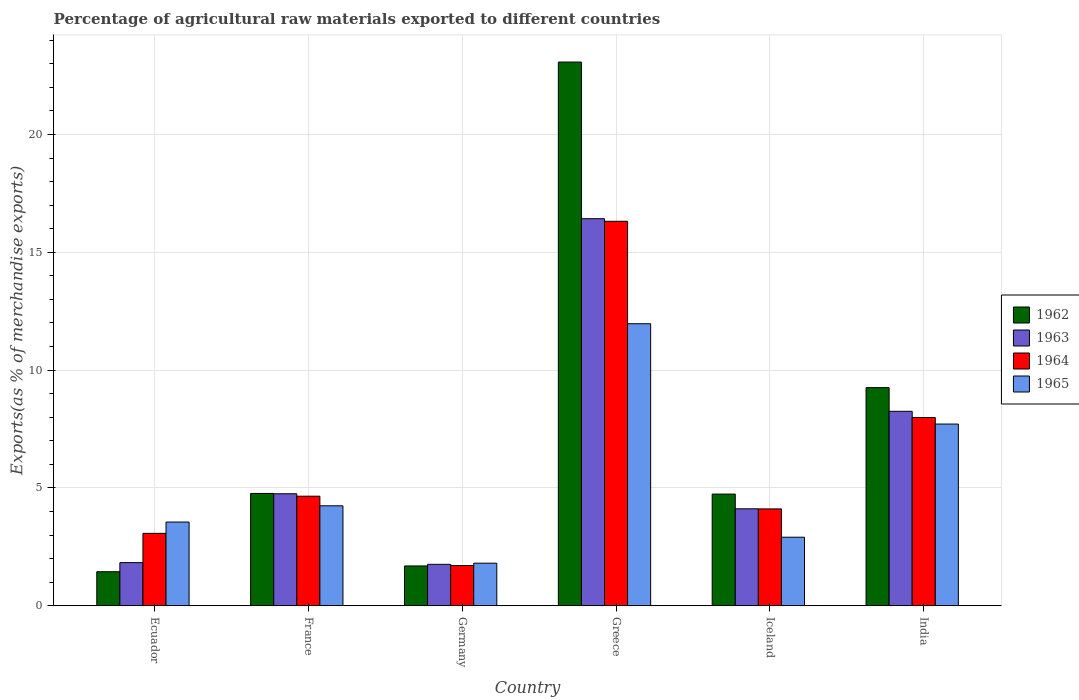How many different coloured bars are there?
Offer a terse response. 4. How many bars are there on the 6th tick from the left?
Provide a short and direct response. 4. How many bars are there on the 4th tick from the right?
Your answer should be very brief. 4. What is the percentage of exports to different countries in 1962 in Iceland?
Your answer should be compact. 4.74. Across all countries, what is the maximum percentage of exports to different countries in 1963?
Offer a terse response. 16.43. Across all countries, what is the minimum percentage of exports to different countries in 1962?
Make the answer very short. 1.45. What is the total percentage of exports to different countries in 1963 in the graph?
Give a very brief answer. 37.14. What is the difference between the percentage of exports to different countries in 1962 in Ecuador and that in India?
Offer a terse response. -7.81. What is the difference between the percentage of exports to different countries in 1962 in Iceland and the percentage of exports to different countries in 1963 in Germany?
Your answer should be compact. 2.98. What is the average percentage of exports to different countries in 1963 per country?
Keep it short and to the point. 6.19. What is the difference between the percentage of exports to different countries of/in 1964 and percentage of exports to different countries of/in 1965 in Greece?
Provide a succinct answer. 4.35. What is the ratio of the percentage of exports to different countries in 1962 in Ecuador to that in Iceland?
Keep it short and to the point. 0.3. What is the difference between the highest and the second highest percentage of exports to different countries in 1962?
Offer a terse response. 4.49. What is the difference between the highest and the lowest percentage of exports to different countries in 1962?
Ensure brevity in your answer.  21.63. Is it the case that in every country, the sum of the percentage of exports to different countries in 1963 and percentage of exports to different countries in 1964 is greater than the sum of percentage of exports to different countries in 1965 and percentage of exports to different countries in 1962?
Give a very brief answer. No. What does the 3rd bar from the left in Greece represents?
Ensure brevity in your answer.  1964. How many bars are there?
Your response must be concise. 24. How many countries are there in the graph?
Ensure brevity in your answer.  6. What is the difference between two consecutive major ticks on the Y-axis?
Provide a succinct answer. 5. Does the graph contain grids?
Your answer should be compact. Yes. How many legend labels are there?
Ensure brevity in your answer.  4. What is the title of the graph?
Provide a short and direct response. Percentage of agricultural raw materials exported to different countries. Does "1969" appear as one of the legend labels in the graph?
Your response must be concise. No. What is the label or title of the X-axis?
Make the answer very short. Country. What is the label or title of the Y-axis?
Offer a very short reply. Exports(as % of merchandise exports). What is the Exports(as % of merchandise exports) of 1962 in Ecuador?
Provide a short and direct response. 1.45. What is the Exports(as % of merchandise exports) of 1963 in Ecuador?
Offer a terse response. 1.83. What is the Exports(as % of merchandise exports) of 1964 in Ecuador?
Your response must be concise. 3.07. What is the Exports(as % of merchandise exports) of 1965 in Ecuador?
Give a very brief answer. 3.55. What is the Exports(as % of merchandise exports) of 1962 in France?
Your answer should be very brief. 4.77. What is the Exports(as % of merchandise exports) of 1963 in France?
Provide a succinct answer. 4.75. What is the Exports(as % of merchandise exports) in 1964 in France?
Your answer should be very brief. 4.65. What is the Exports(as % of merchandise exports) in 1965 in France?
Keep it short and to the point. 4.24. What is the Exports(as % of merchandise exports) in 1962 in Germany?
Provide a succinct answer. 1.69. What is the Exports(as % of merchandise exports) of 1963 in Germany?
Make the answer very short. 1.76. What is the Exports(as % of merchandise exports) in 1964 in Germany?
Your answer should be compact. 1.71. What is the Exports(as % of merchandise exports) of 1965 in Germany?
Keep it short and to the point. 1.81. What is the Exports(as % of merchandise exports) in 1962 in Greece?
Offer a very short reply. 23.07. What is the Exports(as % of merchandise exports) in 1963 in Greece?
Offer a very short reply. 16.43. What is the Exports(as % of merchandise exports) of 1964 in Greece?
Offer a very short reply. 16.32. What is the Exports(as % of merchandise exports) in 1965 in Greece?
Offer a terse response. 11.97. What is the Exports(as % of merchandise exports) in 1962 in Iceland?
Your answer should be compact. 4.74. What is the Exports(as % of merchandise exports) in 1963 in Iceland?
Keep it short and to the point. 4.12. What is the Exports(as % of merchandise exports) in 1964 in Iceland?
Give a very brief answer. 4.11. What is the Exports(as % of merchandise exports) of 1965 in Iceland?
Keep it short and to the point. 2.91. What is the Exports(as % of merchandise exports) of 1962 in India?
Provide a succinct answer. 9.26. What is the Exports(as % of merchandise exports) of 1963 in India?
Provide a short and direct response. 8.25. What is the Exports(as % of merchandise exports) of 1964 in India?
Your answer should be compact. 7.99. What is the Exports(as % of merchandise exports) of 1965 in India?
Provide a short and direct response. 7.71. Across all countries, what is the maximum Exports(as % of merchandise exports) of 1962?
Keep it short and to the point. 23.07. Across all countries, what is the maximum Exports(as % of merchandise exports) of 1963?
Your response must be concise. 16.43. Across all countries, what is the maximum Exports(as % of merchandise exports) in 1964?
Keep it short and to the point. 16.32. Across all countries, what is the maximum Exports(as % of merchandise exports) in 1965?
Make the answer very short. 11.97. Across all countries, what is the minimum Exports(as % of merchandise exports) of 1962?
Offer a terse response. 1.45. Across all countries, what is the minimum Exports(as % of merchandise exports) of 1963?
Offer a terse response. 1.76. Across all countries, what is the minimum Exports(as % of merchandise exports) in 1964?
Give a very brief answer. 1.71. Across all countries, what is the minimum Exports(as % of merchandise exports) in 1965?
Keep it short and to the point. 1.81. What is the total Exports(as % of merchandise exports) of 1962 in the graph?
Provide a short and direct response. 44.97. What is the total Exports(as % of merchandise exports) in 1963 in the graph?
Offer a terse response. 37.14. What is the total Exports(as % of merchandise exports) of 1964 in the graph?
Your response must be concise. 37.85. What is the total Exports(as % of merchandise exports) in 1965 in the graph?
Give a very brief answer. 32.2. What is the difference between the Exports(as % of merchandise exports) in 1962 in Ecuador and that in France?
Your answer should be compact. -3.32. What is the difference between the Exports(as % of merchandise exports) in 1963 in Ecuador and that in France?
Your answer should be compact. -2.92. What is the difference between the Exports(as % of merchandise exports) in 1964 in Ecuador and that in France?
Offer a very short reply. -1.58. What is the difference between the Exports(as % of merchandise exports) in 1965 in Ecuador and that in France?
Your response must be concise. -0.69. What is the difference between the Exports(as % of merchandise exports) in 1962 in Ecuador and that in Germany?
Offer a terse response. -0.24. What is the difference between the Exports(as % of merchandise exports) in 1963 in Ecuador and that in Germany?
Keep it short and to the point. 0.07. What is the difference between the Exports(as % of merchandise exports) in 1964 in Ecuador and that in Germany?
Your answer should be very brief. 1.37. What is the difference between the Exports(as % of merchandise exports) of 1965 in Ecuador and that in Germany?
Make the answer very short. 1.75. What is the difference between the Exports(as % of merchandise exports) of 1962 in Ecuador and that in Greece?
Provide a short and direct response. -21.63. What is the difference between the Exports(as % of merchandise exports) in 1963 in Ecuador and that in Greece?
Provide a short and direct response. -14.59. What is the difference between the Exports(as % of merchandise exports) in 1964 in Ecuador and that in Greece?
Your response must be concise. -13.24. What is the difference between the Exports(as % of merchandise exports) in 1965 in Ecuador and that in Greece?
Your response must be concise. -8.42. What is the difference between the Exports(as % of merchandise exports) of 1962 in Ecuador and that in Iceland?
Your response must be concise. -3.3. What is the difference between the Exports(as % of merchandise exports) of 1963 in Ecuador and that in Iceland?
Provide a short and direct response. -2.28. What is the difference between the Exports(as % of merchandise exports) in 1964 in Ecuador and that in Iceland?
Your response must be concise. -1.04. What is the difference between the Exports(as % of merchandise exports) of 1965 in Ecuador and that in Iceland?
Offer a very short reply. 0.64. What is the difference between the Exports(as % of merchandise exports) of 1962 in Ecuador and that in India?
Your answer should be very brief. -7.81. What is the difference between the Exports(as % of merchandise exports) of 1963 in Ecuador and that in India?
Your answer should be very brief. -6.42. What is the difference between the Exports(as % of merchandise exports) of 1964 in Ecuador and that in India?
Your response must be concise. -4.92. What is the difference between the Exports(as % of merchandise exports) in 1965 in Ecuador and that in India?
Provide a short and direct response. -4.16. What is the difference between the Exports(as % of merchandise exports) in 1962 in France and that in Germany?
Keep it short and to the point. 3.08. What is the difference between the Exports(as % of merchandise exports) of 1963 in France and that in Germany?
Provide a succinct answer. 2.99. What is the difference between the Exports(as % of merchandise exports) of 1964 in France and that in Germany?
Give a very brief answer. 2.94. What is the difference between the Exports(as % of merchandise exports) of 1965 in France and that in Germany?
Keep it short and to the point. 2.43. What is the difference between the Exports(as % of merchandise exports) of 1962 in France and that in Greece?
Keep it short and to the point. -18.3. What is the difference between the Exports(as % of merchandise exports) in 1963 in France and that in Greece?
Ensure brevity in your answer.  -11.67. What is the difference between the Exports(as % of merchandise exports) in 1964 in France and that in Greece?
Your answer should be very brief. -11.66. What is the difference between the Exports(as % of merchandise exports) in 1965 in France and that in Greece?
Your response must be concise. -7.73. What is the difference between the Exports(as % of merchandise exports) in 1962 in France and that in Iceland?
Provide a short and direct response. 0.03. What is the difference between the Exports(as % of merchandise exports) of 1963 in France and that in Iceland?
Keep it short and to the point. 0.64. What is the difference between the Exports(as % of merchandise exports) in 1964 in France and that in Iceland?
Give a very brief answer. 0.54. What is the difference between the Exports(as % of merchandise exports) in 1965 in France and that in Iceland?
Your response must be concise. 1.33. What is the difference between the Exports(as % of merchandise exports) of 1962 in France and that in India?
Keep it short and to the point. -4.49. What is the difference between the Exports(as % of merchandise exports) of 1963 in France and that in India?
Offer a very short reply. -3.5. What is the difference between the Exports(as % of merchandise exports) of 1964 in France and that in India?
Provide a succinct answer. -3.34. What is the difference between the Exports(as % of merchandise exports) in 1965 in France and that in India?
Give a very brief answer. -3.47. What is the difference between the Exports(as % of merchandise exports) in 1962 in Germany and that in Greece?
Your answer should be very brief. -21.38. What is the difference between the Exports(as % of merchandise exports) of 1963 in Germany and that in Greece?
Your response must be concise. -14.67. What is the difference between the Exports(as % of merchandise exports) of 1964 in Germany and that in Greece?
Your answer should be compact. -14.61. What is the difference between the Exports(as % of merchandise exports) in 1965 in Germany and that in Greece?
Give a very brief answer. -10.16. What is the difference between the Exports(as % of merchandise exports) in 1962 in Germany and that in Iceland?
Ensure brevity in your answer.  -3.05. What is the difference between the Exports(as % of merchandise exports) in 1963 in Germany and that in Iceland?
Your response must be concise. -2.36. What is the difference between the Exports(as % of merchandise exports) in 1964 in Germany and that in Iceland?
Your answer should be very brief. -2.4. What is the difference between the Exports(as % of merchandise exports) in 1965 in Germany and that in Iceland?
Offer a terse response. -1.1. What is the difference between the Exports(as % of merchandise exports) in 1962 in Germany and that in India?
Your answer should be compact. -7.57. What is the difference between the Exports(as % of merchandise exports) of 1963 in Germany and that in India?
Your answer should be very brief. -6.49. What is the difference between the Exports(as % of merchandise exports) of 1964 in Germany and that in India?
Give a very brief answer. -6.28. What is the difference between the Exports(as % of merchandise exports) in 1965 in Germany and that in India?
Keep it short and to the point. -5.9. What is the difference between the Exports(as % of merchandise exports) of 1962 in Greece and that in Iceland?
Keep it short and to the point. 18.33. What is the difference between the Exports(as % of merchandise exports) of 1963 in Greece and that in Iceland?
Provide a short and direct response. 12.31. What is the difference between the Exports(as % of merchandise exports) in 1964 in Greece and that in Iceland?
Your answer should be compact. 12.2. What is the difference between the Exports(as % of merchandise exports) of 1965 in Greece and that in Iceland?
Your answer should be compact. 9.06. What is the difference between the Exports(as % of merchandise exports) in 1962 in Greece and that in India?
Your response must be concise. 13.81. What is the difference between the Exports(as % of merchandise exports) of 1963 in Greece and that in India?
Give a very brief answer. 8.17. What is the difference between the Exports(as % of merchandise exports) of 1964 in Greece and that in India?
Your answer should be very brief. 8.33. What is the difference between the Exports(as % of merchandise exports) of 1965 in Greece and that in India?
Provide a succinct answer. 4.26. What is the difference between the Exports(as % of merchandise exports) in 1962 in Iceland and that in India?
Keep it short and to the point. -4.52. What is the difference between the Exports(as % of merchandise exports) in 1963 in Iceland and that in India?
Offer a very short reply. -4.14. What is the difference between the Exports(as % of merchandise exports) of 1964 in Iceland and that in India?
Make the answer very short. -3.88. What is the difference between the Exports(as % of merchandise exports) of 1965 in Iceland and that in India?
Ensure brevity in your answer.  -4.8. What is the difference between the Exports(as % of merchandise exports) of 1962 in Ecuador and the Exports(as % of merchandise exports) of 1963 in France?
Provide a succinct answer. -3.31. What is the difference between the Exports(as % of merchandise exports) in 1962 in Ecuador and the Exports(as % of merchandise exports) in 1964 in France?
Keep it short and to the point. -3.21. What is the difference between the Exports(as % of merchandise exports) of 1962 in Ecuador and the Exports(as % of merchandise exports) of 1965 in France?
Give a very brief answer. -2.8. What is the difference between the Exports(as % of merchandise exports) of 1963 in Ecuador and the Exports(as % of merchandise exports) of 1964 in France?
Your response must be concise. -2.82. What is the difference between the Exports(as % of merchandise exports) in 1963 in Ecuador and the Exports(as % of merchandise exports) in 1965 in France?
Provide a succinct answer. -2.41. What is the difference between the Exports(as % of merchandise exports) in 1964 in Ecuador and the Exports(as % of merchandise exports) in 1965 in France?
Your response must be concise. -1.17. What is the difference between the Exports(as % of merchandise exports) of 1962 in Ecuador and the Exports(as % of merchandise exports) of 1963 in Germany?
Ensure brevity in your answer.  -0.31. What is the difference between the Exports(as % of merchandise exports) in 1962 in Ecuador and the Exports(as % of merchandise exports) in 1964 in Germany?
Ensure brevity in your answer.  -0.26. What is the difference between the Exports(as % of merchandise exports) of 1962 in Ecuador and the Exports(as % of merchandise exports) of 1965 in Germany?
Provide a short and direct response. -0.36. What is the difference between the Exports(as % of merchandise exports) of 1963 in Ecuador and the Exports(as % of merchandise exports) of 1964 in Germany?
Keep it short and to the point. 0.12. What is the difference between the Exports(as % of merchandise exports) of 1963 in Ecuador and the Exports(as % of merchandise exports) of 1965 in Germany?
Your response must be concise. 0.02. What is the difference between the Exports(as % of merchandise exports) in 1964 in Ecuador and the Exports(as % of merchandise exports) in 1965 in Germany?
Offer a very short reply. 1.27. What is the difference between the Exports(as % of merchandise exports) in 1962 in Ecuador and the Exports(as % of merchandise exports) in 1963 in Greece?
Ensure brevity in your answer.  -14.98. What is the difference between the Exports(as % of merchandise exports) in 1962 in Ecuador and the Exports(as % of merchandise exports) in 1964 in Greece?
Give a very brief answer. -14.87. What is the difference between the Exports(as % of merchandise exports) in 1962 in Ecuador and the Exports(as % of merchandise exports) in 1965 in Greece?
Provide a short and direct response. -10.52. What is the difference between the Exports(as % of merchandise exports) in 1963 in Ecuador and the Exports(as % of merchandise exports) in 1964 in Greece?
Provide a short and direct response. -14.48. What is the difference between the Exports(as % of merchandise exports) of 1963 in Ecuador and the Exports(as % of merchandise exports) of 1965 in Greece?
Ensure brevity in your answer.  -10.14. What is the difference between the Exports(as % of merchandise exports) of 1964 in Ecuador and the Exports(as % of merchandise exports) of 1965 in Greece?
Provide a short and direct response. -8.89. What is the difference between the Exports(as % of merchandise exports) of 1962 in Ecuador and the Exports(as % of merchandise exports) of 1963 in Iceland?
Make the answer very short. -2.67. What is the difference between the Exports(as % of merchandise exports) of 1962 in Ecuador and the Exports(as % of merchandise exports) of 1964 in Iceland?
Offer a terse response. -2.67. What is the difference between the Exports(as % of merchandise exports) in 1962 in Ecuador and the Exports(as % of merchandise exports) in 1965 in Iceland?
Keep it short and to the point. -1.46. What is the difference between the Exports(as % of merchandise exports) in 1963 in Ecuador and the Exports(as % of merchandise exports) in 1964 in Iceland?
Provide a succinct answer. -2.28. What is the difference between the Exports(as % of merchandise exports) of 1963 in Ecuador and the Exports(as % of merchandise exports) of 1965 in Iceland?
Provide a succinct answer. -1.08. What is the difference between the Exports(as % of merchandise exports) in 1964 in Ecuador and the Exports(as % of merchandise exports) in 1965 in Iceland?
Your answer should be very brief. 0.16. What is the difference between the Exports(as % of merchandise exports) of 1962 in Ecuador and the Exports(as % of merchandise exports) of 1963 in India?
Your response must be concise. -6.81. What is the difference between the Exports(as % of merchandise exports) in 1962 in Ecuador and the Exports(as % of merchandise exports) in 1964 in India?
Your answer should be very brief. -6.54. What is the difference between the Exports(as % of merchandise exports) in 1962 in Ecuador and the Exports(as % of merchandise exports) in 1965 in India?
Keep it short and to the point. -6.27. What is the difference between the Exports(as % of merchandise exports) of 1963 in Ecuador and the Exports(as % of merchandise exports) of 1964 in India?
Offer a very short reply. -6.16. What is the difference between the Exports(as % of merchandise exports) of 1963 in Ecuador and the Exports(as % of merchandise exports) of 1965 in India?
Offer a very short reply. -5.88. What is the difference between the Exports(as % of merchandise exports) in 1964 in Ecuador and the Exports(as % of merchandise exports) in 1965 in India?
Provide a succinct answer. -4.64. What is the difference between the Exports(as % of merchandise exports) in 1962 in France and the Exports(as % of merchandise exports) in 1963 in Germany?
Ensure brevity in your answer.  3.01. What is the difference between the Exports(as % of merchandise exports) in 1962 in France and the Exports(as % of merchandise exports) in 1964 in Germany?
Your answer should be compact. 3.06. What is the difference between the Exports(as % of merchandise exports) in 1962 in France and the Exports(as % of merchandise exports) in 1965 in Germany?
Your answer should be very brief. 2.96. What is the difference between the Exports(as % of merchandise exports) of 1963 in France and the Exports(as % of merchandise exports) of 1964 in Germany?
Offer a terse response. 3.05. What is the difference between the Exports(as % of merchandise exports) in 1963 in France and the Exports(as % of merchandise exports) in 1965 in Germany?
Your response must be concise. 2.94. What is the difference between the Exports(as % of merchandise exports) in 1964 in France and the Exports(as % of merchandise exports) in 1965 in Germany?
Provide a short and direct response. 2.84. What is the difference between the Exports(as % of merchandise exports) of 1962 in France and the Exports(as % of merchandise exports) of 1963 in Greece?
Offer a terse response. -11.66. What is the difference between the Exports(as % of merchandise exports) in 1962 in France and the Exports(as % of merchandise exports) in 1964 in Greece?
Offer a terse response. -11.55. What is the difference between the Exports(as % of merchandise exports) in 1962 in France and the Exports(as % of merchandise exports) in 1965 in Greece?
Make the answer very short. -7.2. What is the difference between the Exports(as % of merchandise exports) in 1963 in France and the Exports(as % of merchandise exports) in 1964 in Greece?
Provide a succinct answer. -11.56. What is the difference between the Exports(as % of merchandise exports) of 1963 in France and the Exports(as % of merchandise exports) of 1965 in Greece?
Provide a succinct answer. -7.22. What is the difference between the Exports(as % of merchandise exports) of 1964 in France and the Exports(as % of merchandise exports) of 1965 in Greece?
Make the answer very short. -7.32. What is the difference between the Exports(as % of merchandise exports) in 1962 in France and the Exports(as % of merchandise exports) in 1963 in Iceland?
Offer a very short reply. 0.65. What is the difference between the Exports(as % of merchandise exports) of 1962 in France and the Exports(as % of merchandise exports) of 1964 in Iceland?
Offer a very short reply. 0.66. What is the difference between the Exports(as % of merchandise exports) in 1962 in France and the Exports(as % of merchandise exports) in 1965 in Iceland?
Offer a very short reply. 1.86. What is the difference between the Exports(as % of merchandise exports) in 1963 in France and the Exports(as % of merchandise exports) in 1964 in Iceland?
Your answer should be very brief. 0.64. What is the difference between the Exports(as % of merchandise exports) of 1963 in France and the Exports(as % of merchandise exports) of 1965 in Iceland?
Ensure brevity in your answer.  1.84. What is the difference between the Exports(as % of merchandise exports) of 1964 in France and the Exports(as % of merchandise exports) of 1965 in Iceland?
Offer a terse response. 1.74. What is the difference between the Exports(as % of merchandise exports) of 1962 in France and the Exports(as % of merchandise exports) of 1963 in India?
Give a very brief answer. -3.49. What is the difference between the Exports(as % of merchandise exports) of 1962 in France and the Exports(as % of merchandise exports) of 1964 in India?
Keep it short and to the point. -3.22. What is the difference between the Exports(as % of merchandise exports) of 1962 in France and the Exports(as % of merchandise exports) of 1965 in India?
Your response must be concise. -2.94. What is the difference between the Exports(as % of merchandise exports) of 1963 in France and the Exports(as % of merchandise exports) of 1964 in India?
Offer a terse response. -3.24. What is the difference between the Exports(as % of merchandise exports) in 1963 in France and the Exports(as % of merchandise exports) in 1965 in India?
Your response must be concise. -2.96. What is the difference between the Exports(as % of merchandise exports) of 1964 in France and the Exports(as % of merchandise exports) of 1965 in India?
Keep it short and to the point. -3.06. What is the difference between the Exports(as % of merchandise exports) of 1962 in Germany and the Exports(as % of merchandise exports) of 1963 in Greece?
Give a very brief answer. -14.74. What is the difference between the Exports(as % of merchandise exports) of 1962 in Germany and the Exports(as % of merchandise exports) of 1964 in Greece?
Offer a very short reply. -14.63. What is the difference between the Exports(as % of merchandise exports) of 1962 in Germany and the Exports(as % of merchandise exports) of 1965 in Greece?
Provide a short and direct response. -10.28. What is the difference between the Exports(as % of merchandise exports) of 1963 in Germany and the Exports(as % of merchandise exports) of 1964 in Greece?
Your response must be concise. -14.56. What is the difference between the Exports(as % of merchandise exports) of 1963 in Germany and the Exports(as % of merchandise exports) of 1965 in Greece?
Your response must be concise. -10.21. What is the difference between the Exports(as % of merchandise exports) of 1964 in Germany and the Exports(as % of merchandise exports) of 1965 in Greece?
Your answer should be very brief. -10.26. What is the difference between the Exports(as % of merchandise exports) in 1962 in Germany and the Exports(as % of merchandise exports) in 1963 in Iceland?
Offer a terse response. -2.43. What is the difference between the Exports(as % of merchandise exports) of 1962 in Germany and the Exports(as % of merchandise exports) of 1964 in Iceland?
Provide a succinct answer. -2.42. What is the difference between the Exports(as % of merchandise exports) in 1962 in Germany and the Exports(as % of merchandise exports) in 1965 in Iceland?
Ensure brevity in your answer.  -1.22. What is the difference between the Exports(as % of merchandise exports) of 1963 in Germany and the Exports(as % of merchandise exports) of 1964 in Iceland?
Provide a short and direct response. -2.35. What is the difference between the Exports(as % of merchandise exports) in 1963 in Germany and the Exports(as % of merchandise exports) in 1965 in Iceland?
Your answer should be compact. -1.15. What is the difference between the Exports(as % of merchandise exports) in 1964 in Germany and the Exports(as % of merchandise exports) in 1965 in Iceland?
Your answer should be very brief. -1.2. What is the difference between the Exports(as % of merchandise exports) of 1962 in Germany and the Exports(as % of merchandise exports) of 1963 in India?
Make the answer very short. -6.56. What is the difference between the Exports(as % of merchandise exports) in 1962 in Germany and the Exports(as % of merchandise exports) in 1964 in India?
Make the answer very short. -6.3. What is the difference between the Exports(as % of merchandise exports) in 1962 in Germany and the Exports(as % of merchandise exports) in 1965 in India?
Offer a terse response. -6.02. What is the difference between the Exports(as % of merchandise exports) of 1963 in Germany and the Exports(as % of merchandise exports) of 1964 in India?
Make the answer very short. -6.23. What is the difference between the Exports(as % of merchandise exports) of 1963 in Germany and the Exports(as % of merchandise exports) of 1965 in India?
Give a very brief answer. -5.95. What is the difference between the Exports(as % of merchandise exports) of 1964 in Germany and the Exports(as % of merchandise exports) of 1965 in India?
Offer a terse response. -6. What is the difference between the Exports(as % of merchandise exports) of 1962 in Greece and the Exports(as % of merchandise exports) of 1963 in Iceland?
Your response must be concise. 18.96. What is the difference between the Exports(as % of merchandise exports) in 1962 in Greece and the Exports(as % of merchandise exports) in 1964 in Iceland?
Keep it short and to the point. 18.96. What is the difference between the Exports(as % of merchandise exports) in 1962 in Greece and the Exports(as % of merchandise exports) in 1965 in Iceland?
Keep it short and to the point. 20.16. What is the difference between the Exports(as % of merchandise exports) of 1963 in Greece and the Exports(as % of merchandise exports) of 1964 in Iceland?
Your answer should be very brief. 12.31. What is the difference between the Exports(as % of merchandise exports) in 1963 in Greece and the Exports(as % of merchandise exports) in 1965 in Iceland?
Ensure brevity in your answer.  13.52. What is the difference between the Exports(as % of merchandise exports) in 1964 in Greece and the Exports(as % of merchandise exports) in 1965 in Iceland?
Give a very brief answer. 13.41. What is the difference between the Exports(as % of merchandise exports) of 1962 in Greece and the Exports(as % of merchandise exports) of 1963 in India?
Give a very brief answer. 14.82. What is the difference between the Exports(as % of merchandise exports) in 1962 in Greece and the Exports(as % of merchandise exports) in 1964 in India?
Your answer should be compact. 15.08. What is the difference between the Exports(as % of merchandise exports) in 1962 in Greece and the Exports(as % of merchandise exports) in 1965 in India?
Offer a very short reply. 15.36. What is the difference between the Exports(as % of merchandise exports) in 1963 in Greece and the Exports(as % of merchandise exports) in 1964 in India?
Provide a short and direct response. 8.44. What is the difference between the Exports(as % of merchandise exports) in 1963 in Greece and the Exports(as % of merchandise exports) in 1965 in India?
Your response must be concise. 8.71. What is the difference between the Exports(as % of merchandise exports) in 1964 in Greece and the Exports(as % of merchandise exports) in 1965 in India?
Your response must be concise. 8.6. What is the difference between the Exports(as % of merchandise exports) of 1962 in Iceland and the Exports(as % of merchandise exports) of 1963 in India?
Ensure brevity in your answer.  -3.51. What is the difference between the Exports(as % of merchandise exports) of 1962 in Iceland and the Exports(as % of merchandise exports) of 1964 in India?
Make the answer very short. -3.25. What is the difference between the Exports(as % of merchandise exports) of 1962 in Iceland and the Exports(as % of merchandise exports) of 1965 in India?
Provide a succinct answer. -2.97. What is the difference between the Exports(as % of merchandise exports) in 1963 in Iceland and the Exports(as % of merchandise exports) in 1964 in India?
Offer a very short reply. -3.87. What is the difference between the Exports(as % of merchandise exports) of 1963 in Iceland and the Exports(as % of merchandise exports) of 1965 in India?
Your response must be concise. -3.6. What is the difference between the Exports(as % of merchandise exports) of 1964 in Iceland and the Exports(as % of merchandise exports) of 1965 in India?
Offer a terse response. -3.6. What is the average Exports(as % of merchandise exports) in 1962 per country?
Keep it short and to the point. 7.5. What is the average Exports(as % of merchandise exports) of 1963 per country?
Keep it short and to the point. 6.19. What is the average Exports(as % of merchandise exports) of 1964 per country?
Your answer should be very brief. 6.31. What is the average Exports(as % of merchandise exports) of 1965 per country?
Offer a terse response. 5.37. What is the difference between the Exports(as % of merchandise exports) of 1962 and Exports(as % of merchandise exports) of 1963 in Ecuador?
Make the answer very short. -0.39. What is the difference between the Exports(as % of merchandise exports) of 1962 and Exports(as % of merchandise exports) of 1964 in Ecuador?
Your answer should be very brief. -1.63. What is the difference between the Exports(as % of merchandise exports) in 1962 and Exports(as % of merchandise exports) in 1965 in Ecuador?
Provide a short and direct response. -2.11. What is the difference between the Exports(as % of merchandise exports) of 1963 and Exports(as % of merchandise exports) of 1964 in Ecuador?
Make the answer very short. -1.24. What is the difference between the Exports(as % of merchandise exports) of 1963 and Exports(as % of merchandise exports) of 1965 in Ecuador?
Offer a very short reply. -1.72. What is the difference between the Exports(as % of merchandise exports) in 1964 and Exports(as % of merchandise exports) in 1965 in Ecuador?
Provide a short and direct response. -0.48. What is the difference between the Exports(as % of merchandise exports) in 1962 and Exports(as % of merchandise exports) in 1963 in France?
Your response must be concise. 0.01. What is the difference between the Exports(as % of merchandise exports) in 1962 and Exports(as % of merchandise exports) in 1964 in France?
Provide a succinct answer. 0.12. What is the difference between the Exports(as % of merchandise exports) of 1962 and Exports(as % of merchandise exports) of 1965 in France?
Keep it short and to the point. 0.52. What is the difference between the Exports(as % of merchandise exports) of 1963 and Exports(as % of merchandise exports) of 1964 in France?
Offer a terse response. 0.1. What is the difference between the Exports(as % of merchandise exports) of 1963 and Exports(as % of merchandise exports) of 1965 in France?
Ensure brevity in your answer.  0.51. What is the difference between the Exports(as % of merchandise exports) of 1964 and Exports(as % of merchandise exports) of 1965 in France?
Keep it short and to the point. 0.41. What is the difference between the Exports(as % of merchandise exports) in 1962 and Exports(as % of merchandise exports) in 1963 in Germany?
Keep it short and to the point. -0.07. What is the difference between the Exports(as % of merchandise exports) in 1962 and Exports(as % of merchandise exports) in 1964 in Germany?
Keep it short and to the point. -0.02. What is the difference between the Exports(as % of merchandise exports) in 1962 and Exports(as % of merchandise exports) in 1965 in Germany?
Offer a terse response. -0.12. What is the difference between the Exports(as % of merchandise exports) of 1963 and Exports(as % of merchandise exports) of 1964 in Germany?
Give a very brief answer. 0.05. What is the difference between the Exports(as % of merchandise exports) of 1963 and Exports(as % of merchandise exports) of 1965 in Germany?
Offer a terse response. -0.05. What is the difference between the Exports(as % of merchandise exports) of 1964 and Exports(as % of merchandise exports) of 1965 in Germany?
Your answer should be compact. -0.1. What is the difference between the Exports(as % of merchandise exports) of 1962 and Exports(as % of merchandise exports) of 1963 in Greece?
Your answer should be compact. 6.65. What is the difference between the Exports(as % of merchandise exports) in 1962 and Exports(as % of merchandise exports) in 1964 in Greece?
Offer a terse response. 6.76. What is the difference between the Exports(as % of merchandise exports) of 1962 and Exports(as % of merchandise exports) of 1965 in Greece?
Provide a succinct answer. 11.1. What is the difference between the Exports(as % of merchandise exports) in 1963 and Exports(as % of merchandise exports) in 1964 in Greece?
Ensure brevity in your answer.  0.11. What is the difference between the Exports(as % of merchandise exports) in 1963 and Exports(as % of merchandise exports) in 1965 in Greece?
Your response must be concise. 4.46. What is the difference between the Exports(as % of merchandise exports) of 1964 and Exports(as % of merchandise exports) of 1965 in Greece?
Ensure brevity in your answer.  4.35. What is the difference between the Exports(as % of merchandise exports) of 1962 and Exports(as % of merchandise exports) of 1963 in Iceland?
Your answer should be compact. 0.63. What is the difference between the Exports(as % of merchandise exports) of 1962 and Exports(as % of merchandise exports) of 1964 in Iceland?
Provide a short and direct response. 0.63. What is the difference between the Exports(as % of merchandise exports) in 1962 and Exports(as % of merchandise exports) in 1965 in Iceland?
Keep it short and to the point. 1.83. What is the difference between the Exports(as % of merchandise exports) of 1963 and Exports(as % of merchandise exports) of 1964 in Iceland?
Ensure brevity in your answer.  0. What is the difference between the Exports(as % of merchandise exports) of 1963 and Exports(as % of merchandise exports) of 1965 in Iceland?
Provide a short and direct response. 1.21. What is the difference between the Exports(as % of merchandise exports) of 1964 and Exports(as % of merchandise exports) of 1965 in Iceland?
Your response must be concise. 1.2. What is the difference between the Exports(as % of merchandise exports) of 1962 and Exports(as % of merchandise exports) of 1964 in India?
Keep it short and to the point. 1.27. What is the difference between the Exports(as % of merchandise exports) of 1962 and Exports(as % of merchandise exports) of 1965 in India?
Ensure brevity in your answer.  1.55. What is the difference between the Exports(as % of merchandise exports) in 1963 and Exports(as % of merchandise exports) in 1964 in India?
Offer a terse response. 0.26. What is the difference between the Exports(as % of merchandise exports) in 1963 and Exports(as % of merchandise exports) in 1965 in India?
Give a very brief answer. 0.54. What is the difference between the Exports(as % of merchandise exports) of 1964 and Exports(as % of merchandise exports) of 1965 in India?
Provide a short and direct response. 0.28. What is the ratio of the Exports(as % of merchandise exports) of 1962 in Ecuador to that in France?
Keep it short and to the point. 0.3. What is the ratio of the Exports(as % of merchandise exports) in 1963 in Ecuador to that in France?
Offer a very short reply. 0.39. What is the ratio of the Exports(as % of merchandise exports) in 1964 in Ecuador to that in France?
Provide a short and direct response. 0.66. What is the ratio of the Exports(as % of merchandise exports) in 1965 in Ecuador to that in France?
Ensure brevity in your answer.  0.84. What is the ratio of the Exports(as % of merchandise exports) in 1962 in Ecuador to that in Germany?
Ensure brevity in your answer.  0.86. What is the ratio of the Exports(as % of merchandise exports) in 1963 in Ecuador to that in Germany?
Provide a short and direct response. 1.04. What is the ratio of the Exports(as % of merchandise exports) of 1964 in Ecuador to that in Germany?
Make the answer very short. 1.8. What is the ratio of the Exports(as % of merchandise exports) of 1965 in Ecuador to that in Germany?
Your response must be concise. 1.96. What is the ratio of the Exports(as % of merchandise exports) of 1962 in Ecuador to that in Greece?
Provide a short and direct response. 0.06. What is the ratio of the Exports(as % of merchandise exports) of 1963 in Ecuador to that in Greece?
Offer a terse response. 0.11. What is the ratio of the Exports(as % of merchandise exports) of 1964 in Ecuador to that in Greece?
Your answer should be very brief. 0.19. What is the ratio of the Exports(as % of merchandise exports) in 1965 in Ecuador to that in Greece?
Make the answer very short. 0.3. What is the ratio of the Exports(as % of merchandise exports) in 1962 in Ecuador to that in Iceland?
Provide a succinct answer. 0.3. What is the ratio of the Exports(as % of merchandise exports) of 1963 in Ecuador to that in Iceland?
Give a very brief answer. 0.45. What is the ratio of the Exports(as % of merchandise exports) of 1964 in Ecuador to that in Iceland?
Keep it short and to the point. 0.75. What is the ratio of the Exports(as % of merchandise exports) in 1965 in Ecuador to that in Iceland?
Keep it short and to the point. 1.22. What is the ratio of the Exports(as % of merchandise exports) in 1962 in Ecuador to that in India?
Your answer should be compact. 0.16. What is the ratio of the Exports(as % of merchandise exports) of 1963 in Ecuador to that in India?
Give a very brief answer. 0.22. What is the ratio of the Exports(as % of merchandise exports) of 1964 in Ecuador to that in India?
Offer a terse response. 0.38. What is the ratio of the Exports(as % of merchandise exports) of 1965 in Ecuador to that in India?
Provide a succinct answer. 0.46. What is the ratio of the Exports(as % of merchandise exports) of 1962 in France to that in Germany?
Provide a short and direct response. 2.82. What is the ratio of the Exports(as % of merchandise exports) in 1963 in France to that in Germany?
Provide a succinct answer. 2.7. What is the ratio of the Exports(as % of merchandise exports) of 1964 in France to that in Germany?
Give a very brief answer. 2.72. What is the ratio of the Exports(as % of merchandise exports) in 1965 in France to that in Germany?
Offer a terse response. 2.35. What is the ratio of the Exports(as % of merchandise exports) of 1962 in France to that in Greece?
Your response must be concise. 0.21. What is the ratio of the Exports(as % of merchandise exports) of 1963 in France to that in Greece?
Give a very brief answer. 0.29. What is the ratio of the Exports(as % of merchandise exports) in 1964 in France to that in Greece?
Provide a short and direct response. 0.29. What is the ratio of the Exports(as % of merchandise exports) in 1965 in France to that in Greece?
Offer a terse response. 0.35. What is the ratio of the Exports(as % of merchandise exports) of 1963 in France to that in Iceland?
Your answer should be very brief. 1.16. What is the ratio of the Exports(as % of merchandise exports) in 1964 in France to that in Iceland?
Your answer should be compact. 1.13. What is the ratio of the Exports(as % of merchandise exports) in 1965 in France to that in Iceland?
Offer a terse response. 1.46. What is the ratio of the Exports(as % of merchandise exports) of 1962 in France to that in India?
Give a very brief answer. 0.51. What is the ratio of the Exports(as % of merchandise exports) of 1963 in France to that in India?
Offer a terse response. 0.58. What is the ratio of the Exports(as % of merchandise exports) of 1964 in France to that in India?
Your response must be concise. 0.58. What is the ratio of the Exports(as % of merchandise exports) in 1965 in France to that in India?
Your response must be concise. 0.55. What is the ratio of the Exports(as % of merchandise exports) in 1962 in Germany to that in Greece?
Your response must be concise. 0.07. What is the ratio of the Exports(as % of merchandise exports) of 1963 in Germany to that in Greece?
Provide a short and direct response. 0.11. What is the ratio of the Exports(as % of merchandise exports) of 1964 in Germany to that in Greece?
Your answer should be compact. 0.1. What is the ratio of the Exports(as % of merchandise exports) of 1965 in Germany to that in Greece?
Ensure brevity in your answer.  0.15. What is the ratio of the Exports(as % of merchandise exports) in 1962 in Germany to that in Iceland?
Provide a short and direct response. 0.36. What is the ratio of the Exports(as % of merchandise exports) in 1963 in Germany to that in Iceland?
Provide a short and direct response. 0.43. What is the ratio of the Exports(as % of merchandise exports) of 1964 in Germany to that in Iceland?
Your answer should be very brief. 0.42. What is the ratio of the Exports(as % of merchandise exports) of 1965 in Germany to that in Iceland?
Give a very brief answer. 0.62. What is the ratio of the Exports(as % of merchandise exports) in 1962 in Germany to that in India?
Provide a succinct answer. 0.18. What is the ratio of the Exports(as % of merchandise exports) of 1963 in Germany to that in India?
Your answer should be very brief. 0.21. What is the ratio of the Exports(as % of merchandise exports) in 1964 in Germany to that in India?
Give a very brief answer. 0.21. What is the ratio of the Exports(as % of merchandise exports) of 1965 in Germany to that in India?
Ensure brevity in your answer.  0.23. What is the ratio of the Exports(as % of merchandise exports) in 1962 in Greece to that in Iceland?
Make the answer very short. 4.87. What is the ratio of the Exports(as % of merchandise exports) of 1963 in Greece to that in Iceland?
Your answer should be compact. 3.99. What is the ratio of the Exports(as % of merchandise exports) in 1964 in Greece to that in Iceland?
Give a very brief answer. 3.97. What is the ratio of the Exports(as % of merchandise exports) in 1965 in Greece to that in Iceland?
Give a very brief answer. 4.11. What is the ratio of the Exports(as % of merchandise exports) in 1962 in Greece to that in India?
Keep it short and to the point. 2.49. What is the ratio of the Exports(as % of merchandise exports) of 1963 in Greece to that in India?
Your answer should be compact. 1.99. What is the ratio of the Exports(as % of merchandise exports) in 1964 in Greece to that in India?
Your answer should be compact. 2.04. What is the ratio of the Exports(as % of merchandise exports) of 1965 in Greece to that in India?
Your answer should be compact. 1.55. What is the ratio of the Exports(as % of merchandise exports) in 1962 in Iceland to that in India?
Your answer should be compact. 0.51. What is the ratio of the Exports(as % of merchandise exports) in 1963 in Iceland to that in India?
Offer a very short reply. 0.5. What is the ratio of the Exports(as % of merchandise exports) of 1964 in Iceland to that in India?
Your answer should be compact. 0.51. What is the ratio of the Exports(as % of merchandise exports) in 1965 in Iceland to that in India?
Provide a short and direct response. 0.38. What is the difference between the highest and the second highest Exports(as % of merchandise exports) in 1962?
Make the answer very short. 13.81. What is the difference between the highest and the second highest Exports(as % of merchandise exports) in 1963?
Provide a short and direct response. 8.17. What is the difference between the highest and the second highest Exports(as % of merchandise exports) in 1964?
Offer a very short reply. 8.33. What is the difference between the highest and the second highest Exports(as % of merchandise exports) in 1965?
Provide a short and direct response. 4.26. What is the difference between the highest and the lowest Exports(as % of merchandise exports) in 1962?
Ensure brevity in your answer.  21.63. What is the difference between the highest and the lowest Exports(as % of merchandise exports) in 1963?
Give a very brief answer. 14.67. What is the difference between the highest and the lowest Exports(as % of merchandise exports) in 1964?
Keep it short and to the point. 14.61. What is the difference between the highest and the lowest Exports(as % of merchandise exports) in 1965?
Make the answer very short. 10.16. 